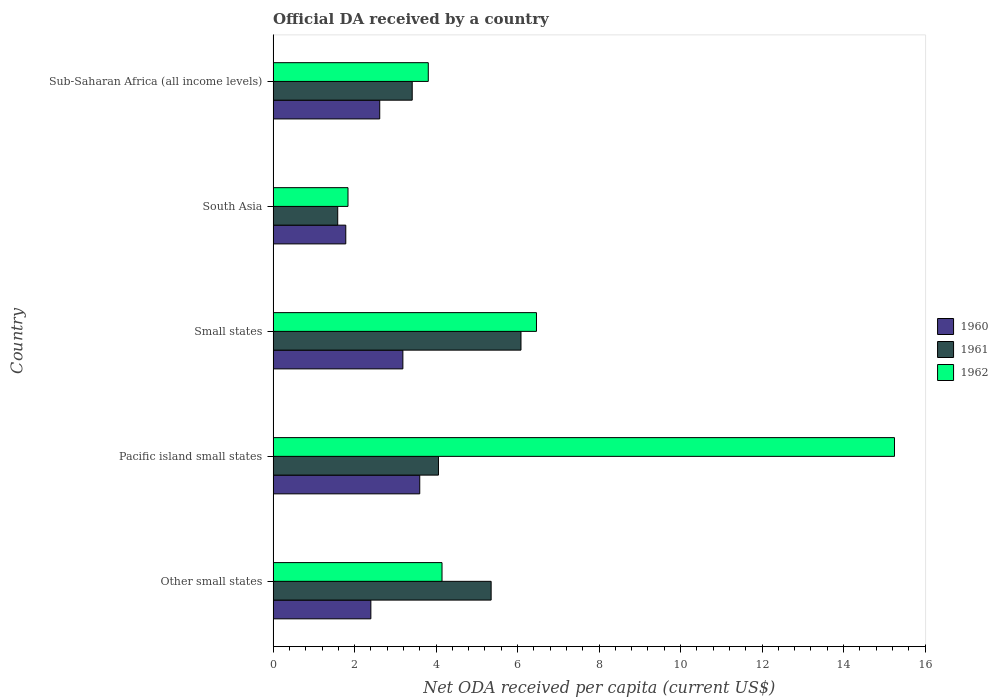Are the number of bars per tick equal to the number of legend labels?
Offer a very short reply. Yes. Are the number of bars on each tick of the Y-axis equal?
Keep it short and to the point. Yes. How many bars are there on the 5th tick from the bottom?
Keep it short and to the point. 3. What is the label of the 3rd group of bars from the top?
Give a very brief answer. Small states. What is the ODA received in in 1961 in Small states?
Your answer should be compact. 6.08. Across all countries, what is the maximum ODA received in in 1962?
Ensure brevity in your answer.  15.25. Across all countries, what is the minimum ODA received in in 1962?
Offer a very short reply. 1.84. In which country was the ODA received in in 1960 maximum?
Provide a succinct answer. Pacific island small states. What is the total ODA received in in 1961 in the graph?
Offer a very short reply. 20.49. What is the difference between the ODA received in in 1961 in Other small states and that in Pacific island small states?
Keep it short and to the point. 1.29. What is the difference between the ODA received in in 1961 in South Asia and the ODA received in in 1960 in Small states?
Offer a very short reply. -1.6. What is the average ODA received in in 1960 per country?
Provide a short and direct response. 2.72. What is the difference between the ODA received in in 1962 and ODA received in in 1961 in Pacific island small states?
Offer a terse response. 11.19. What is the ratio of the ODA received in in 1962 in Small states to that in South Asia?
Provide a succinct answer. 3.52. Is the ODA received in in 1962 in Pacific island small states less than that in South Asia?
Offer a terse response. No. Is the difference between the ODA received in in 1962 in Small states and South Asia greater than the difference between the ODA received in in 1961 in Small states and South Asia?
Offer a very short reply. Yes. What is the difference between the highest and the second highest ODA received in in 1962?
Your answer should be very brief. 8.79. What is the difference between the highest and the lowest ODA received in in 1961?
Provide a succinct answer. 4.5. What does the 2nd bar from the top in Small states represents?
Provide a short and direct response. 1961. What does the 1st bar from the bottom in Pacific island small states represents?
Ensure brevity in your answer.  1960. Is it the case that in every country, the sum of the ODA received in in 1961 and ODA received in in 1962 is greater than the ODA received in in 1960?
Your answer should be very brief. Yes. How many bars are there?
Offer a very short reply. 15. How many countries are there in the graph?
Give a very brief answer. 5. Are the values on the major ticks of X-axis written in scientific E-notation?
Your answer should be compact. No. What is the title of the graph?
Your answer should be very brief. Official DA received by a country. Does "1965" appear as one of the legend labels in the graph?
Your answer should be compact. No. What is the label or title of the X-axis?
Your answer should be compact. Net ODA received per capita (current US$). What is the Net ODA received per capita (current US$) in 1960 in Other small states?
Your response must be concise. 2.4. What is the Net ODA received per capita (current US$) in 1961 in Other small states?
Your answer should be compact. 5.35. What is the Net ODA received per capita (current US$) in 1962 in Other small states?
Make the answer very short. 4.15. What is the Net ODA received per capita (current US$) in 1960 in Pacific island small states?
Provide a short and direct response. 3.6. What is the Net ODA received per capita (current US$) in 1961 in Pacific island small states?
Make the answer very short. 4.06. What is the Net ODA received per capita (current US$) in 1962 in Pacific island small states?
Your answer should be compact. 15.25. What is the Net ODA received per capita (current US$) in 1960 in Small states?
Make the answer very short. 3.18. What is the Net ODA received per capita (current US$) in 1961 in Small states?
Provide a short and direct response. 6.08. What is the Net ODA received per capita (current US$) of 1962 in Small states?
Keep it short and to the point. 6.46. What is the Net ODA received per capita (current US$) of 1960 in South Asia?
Your response must be concise. 1.78. What is the Net ODA received per capita (current US$) of 1961 in South Asia?
Give a very brief answer. 1.59. What is the Net ODA received per capita (current US$) of 1962 in South Asia?
Keep it short and to the point. 1.84. What is the Net ODA received per capita (current US$) in 1960 in Sub-Saharan Africa (all income levels)?
Your answer should be compact. 2.62. What is the Net ODA received per capita (current US$) of 1961 in Sub-Saharan Africa (all income levels)?
Offer a terse response. 3.41. What is the Net ODA received per capita (current US$) in 1962 in Sub-Saharan Africa (all income levels)?
Your response must be concise. 3.81. Across all countries, what is the maximum Net ODA received per capita (current US$) of 1960?
Provide a short and direct response. 3.6. Across all countries, what is the maximum Net ODA received per capita (current US$) of 1961?
Offer a terse response. 6.08. Across all countries, what is the maximum Net ODA received per capita (current US$) in 1962?
Offer a very short reply. 15.25. Across all countries, what is the minimum Net ODA received per capita (current US$) in 1960?
Provide a short and direct response. 1.78. Across all countries, what is the minimum Net ODA received per capita (current US$) of 1961?
Your answer should be compact. 1.59. Across all countries, what is the minimum Net ODA received per capita (current US$) of 1962?
Offer a terse response. 1.84. What is the total Net ODA received per capita (current US$) in 1960 in the graph?
Keep it short and to the point. 13.58. What is the total Net ODA received per capita (current US$) in 1961 in the graph?
Keep it short and to the point. 20.49. What is the total Net ODA received per capita (current US$) of 1962 in the graph?
Provide a succinct answer. 31.51. What is the difference between the Net ODA received per capita (current US$) of 1961 in Other small states and that in Pacific island small states?
Provide a succinct answer. 1.29. What is the difference between the Net ODA received per capita (current US$) of 1962 in Other small states and that in Pacific island small states?
Provide a short and direct response. -11.11. What is the difference between the Net ODA received per capita (current US$) in 1960 in Other small states and that in Small states?
Offer a terse response. -0.79. What is the difference between the Net ODA received per capita (current US$) of 1961 in Other small states and that in Small states?
Give a very brief answer. -0.73. What is the difference between the Net ODA received per capita (current US$) of 1962 in Other small states and that in Small states?
Offer a very short reply. -2.32. What is the difference between the Net ODA received per capita (current US$) in 1960 in Other small states and that in South Asia?
Make the answer very short. 0.62. What is the difference between the Net ODA received per capita (current US$) in 1961 in Other small states and that in South Asia?
Provide a short and direct response. 3.77. What is the difference between the Net ODA received per capita (current US$) of 1962 in Other small states and that in South Asia?
Offer a terse response. 2.31. What is the difference between the Net ODA received per capita (current US$) of 1960 in Other small states and that in Sub-Saharan Africa (all income levels)?
Offer a terse response. -0.22. What is the difference between the Net ODA received per capita (current US$) in 1961 in Other small states and that in Sub-Saharan Africa (all income levels)?
Make the answer very short. 1.94. What is the difference between the Net ODA received per capita (current US$) of 1962 in Other small states and that in Sub-Saharan Africa (all income levels)?
Your answer should be very brief. 0.34. What is the difference between the Net ODA received per capita (current US$) in 1960 in Pacific island small states and that in Small states?
Provide a short and direct response. 0.41. What is the difference between the Net ODA received per capita (current US$) in 1961 in Pacific island small states and that in Small states?
Keep it short and to the point. -2.03. What is the difference between the Net ODA received per capita (current US$) in 1962 in Pacific island small states and that in Small states?
Provide a succinct answer. 8.79. What is the difference between the Net ODA received per capita (current US$) of 1960 in Pacific island small states and that in South Asia?
Your answer should be compact. 1.82. What is the difference between the Net ODA received per capita (current US$) in 1961 in Pacific island small states and that in South Asia?
Give a very brief answer. 2.47. What is the difference between the Net ODA received per capita (current US$) of 1962 in Pacific island small states and that in South Asia?
Provide a short and direct response. 13.41. What is the difference between the Net ODA received per capita (current US$) of 1960 in Pacific island small states and that in Sub-Saharan Africa (all income levels)?
Offer a very short reply. 0.98. What is the difference between the Net ODA received per capita (current US$) of 1961 in Pacific island small states and that in Sub-Saharan Africa (all income levels)?
Make the answer very short. 0.64. What is the difference between the Net ODA received per capita (current US$) of 1962 in Pacific island small states and that in Sub-Saharan Africa (all income levels)?
Provide a succinct answer. 11.44. What is the difference between the Net ODA received per capita (current US$) of 1960 in Small states and that in South Asia?
Keep it short and to the point. 1.4. What is the difference between the Net ODA received per capita (current US$) in 1961 in Small states and that in South Asia?
Your answer should be compact. 4.5. What is the difference between the Net ODA received per capita (current US$) of 1962 in Small states and that in South Asia?
Provide a succinct answer. 4.63. What is the difference between the Net ODA received per capita (current US$) in 1960 in Small states and that in Sub-Saharan Africa (all income levels)?
Provide a short and direct response. 0.57. What is the difference between the Net ODA received per capita (current US$) of 1961 in Small states and that in Sub-Saharan Africa (all income levels)?
Your response must be concise. 2.67. What is the difference between the Net ODA received per capita (current US$) in 1962 in Small states and that in Sub-Saharan Africa (all income levels)?
Keep it short and to the point. 2.66. What is the difference between the Net ODA received per capita (current US$) in 1960 in South Asia and that in Sub-Saharan Africa (all income levels)?
Provide a succinct answer. -0.83. What is the difference between the Net ODA received per capita (current US$) in 1961 in South Asia and that in Sub-Saharan Africa (all income levels)?
Offer a terse response. -1.83. What is the difference between the Net ODA received per capita (current US$) of 1962 in South Asia and that in Sub-Saharan Africa (all income levels)?
Give a very brief answer. -1.97. What is the difference between the Net ODA received per capita (current US$) of 1960 in Other small states and the Net ODA received per capita (current US$) of 1961 in Pacific island small states?
Make the answer very short. -1.66. What is the difference between the Net ODA received per capita (current US$) of 1960 in Other small states and the Net ODA received per capita (current US$) of 1962 in Pacific island small states?
Provide a succinct answer. -12.85. What is the difference between the Net ODA received per capita (current US$) in 1961 in Other small states and the Net ODA received per capita (current US$) in 1962 in Pacific island small states?
Ensure brevity in your answer.  -9.9. What is the difference between the Net ODA received per capita (current US$) in 1960 in Other small states and the Net ODA received per capita (current US$) in 1961 in Small states?
Provide a short and direct response. -3.69. What is the difference between the Net ODA received per capita (current US$) of 1960 in Other small states and the Net ODA received per capita (current US$) of 1962 in Small states?
Your answer should be compact. -4.06. What is the difference between the Net ODA received per capita (current US$) of 1961 in Other small states and the Net ODA received per capita (current US$) of 1962 in Small states?
Your answer should be compact. -1.11. What is the difference between the Net ODA received per capita (current US$) of 1960 in Other small states and the Net ODA received per capita (current US$) of 1961 in South Asia?
Your response must be concise. 0.81. What is the difference between the Net ODA received per capita (current US$) of 1960 in Other small states and the Net ODA received per capita (current US$) of 1962 in South Asia?
Make the answer very short. 0.56. What is the difference between the Net ODA received per capita (current US$) of 1961 in Other small states and the Net ODA received per capita (current US$) of 1962 in South Asia?
Offer a very short reply. 3.51. What is the difference between the Net ODA received per capita (current US$) in 1960 in Other small states and the Net ODA received per capita (current US$) in 1961 in Sub-Saharan Africa (all income levels)?
Ensure brevity in your answer.  -1.02. What is the difference between the Net ODA received per capita (current US$) in 1960 in Other small states and the Net ODA received per capita (current US$) in 1962 in Sub-Saharan Africa (all income levels)?
Your response must be concise. -1.41. What is the difference between the Net ODA received per capita (current US$) of 1961 in Other small states and the Net ODA received per capita (current US$) of 1962 in Sub-Saharan Africa (all income levels)?
Ensure brevity in your answer.  1.54. What is the difference between the Net ODA received per capita (current US$) in 1960 in Pacific island small states and the Net ODA received per capita (current US$) in 1961 in Small states?
Give a very brief answer. -2.48. What is the difference between the Net ODA received per capita (current US$) in 1960 in Pacific island small states and the Net ODA received per capita (current US$) in 1962 in Small states?
Your answer should be compact. -2.86. What is the difference between the Net ODA received per capita (current US$) in 1961 in Pacific island small states and the Net ODA received per capita (current US$) in 1962 in Small states?
Ensure brevity in your answer.  -2.41. What is the difference between the Net ODA received per capita (current US$) of 1960 in Pacific island small states and the Net ODA received per capita (current US$) of 1961 in South Asia?
Offer a terse response. 2.01. What is the difference between the Net ODA received per capita (current US$) of 1960 in Pacific island small states and the Net ODA received per capita (current US$) of 1962 in South Asia?
Your answer should be very brief. 1.76. What is the difference between the Net ODA received per capita (current US$) of 1961 in Pacific island small states and the Net ODA received per capita (current US$) of 1962 in South Asia?
Your answer should be compact. 2.22. What is the difference between the Net ODA received per capita (current US$) in 1960 in Pacific island small states and the Net ODA received per capita (current US$) in 1961 in Sub-Saharan Africa (all income levels)?
Provide a short and direct response. 0.18. What is the difference between the Net ODA received per capita (current US$) of 1960 in Pacific island small states and the Net ODA received per capita (current US$) of 1962 in Sub-Saharan Africa (all income levels)?
Your answer should be compact. -0.21. What is the difference between the Net ODA received per capita (current US$) in 1961 in Pacific island small states and the Net ODA received per capita (current US$) in 1962 in Sub-Saharan Africa (all income levels)?
Offer a very short reply. 0.25. What is the difference between the Net ODA received per capita (current US$) of 1960 in Small states and the Net ODA received per capita (current US$) of 1961 in South Asia?
Provide a short and direct response. 1.6. What is the difference between the Net ODA received per capita (current US$) in 1960 in Small states and the Net ODA received per capita (current US$) in 1962 in South Asia?
Give a very brief answer. 1.35. What is the difference between the Net ODA received per capita (current US$) of 1961 in Small states and the Net ODA received per capita (current US$) of 1962 in South Asia?
Your answer should be compact. 4.25. What is the difference between the Net ODA received per capita (current US$) of 1960 in Small states and the Net ODA received per capita (current US$) of 1961 in Sub-Saharan Africa (all income levels)?
Ensure brevity in your answer.  -0.23. What is the difference between the Net ODA received per capita (current US$) in 1960 in Small states and the Net ODA received per capita (current US$) in 1962 in Sub-Saharan Africa (all income levels)?
Offer a very short reply. -0.62. What is the difference between the Net ODA received per capita (current US$) of 1961 in Small states and the Net ODA received per capita (current US$) of 1962 in Sub-Saharan Africa (all income levels)?
Keep it short and to the point. 2.28. What is the difference between the Net ODA received per capita (current US$) of 1960 in South Asia and the Net ODA received per capita (current US$) of 1961 in Sub-Saharan Africa (all income levels)?
Provide a short and direct response. -1.63. What is the difference between the Net ODA received per capita (current US$) of 1960 in South Asia and the Net ODA received per capita (current US$) of 1962 in Sub-Saharan Africa (all income levels)?
Your response must be concise. -2.02. What is the difference between the Net ODA received per capita (current US$) of 1961 in South Asia and the Net ODA received per capita (current US$) of 1962 in Sub-Saharan Africa (all income levels)?
Keep it short and to the point. -2.22. What is the average Net ODA received per capita (current US$) in 1960 per country?
Offer a terse response. 2.72. What is the average Net ODA received per capita (current US$) of 1961 per country?
Offer a very short reply. 4.1. What is the average Net ODA received per capita (current US$) of 1962 per country?
Offer a very short reply. 6.3. What is the difference between the Net ODA received per capita (current US$) in 1960 and Net ODA received per capita (current US$) in 1961 in Other small states?
Offer a very short reply. -2.95. What is the difference between the Net ODA received per capita (current US$) in 1960 and Net ODA received per capita (current US$) in 1962 in Other small states?
Keep it short and to the point. -1.75. What is the difference between the Net ODA received per capita (current US$) of 1961 and Net ODA received per capita (current US$) of 1962 in Other small states?
Your answer should be very brief. 1.21. What is the difference between the Net ODA received per capita (current US$) of 1960 and Net ODA received per capita (current US$) of 1961 in Pacific island small states?
Your answer should be very brief. -0.46. What is the difference between the Net ODA received per capita (current US$) of 1960 and Net ODA received per capita (current US$) of 1962 in Pacific island small states?
Offer a very short reply. -11.65. What is the difference between the Net ODA received per capita (current US$) of 1961 and Net ODA received per capita (current US$) of 1962 in Pacific island small states?
Keep it short and to the point. -11.19. What is the difference between the Net ODA received per capita (current US$) in 1960 and Net ODA received per capita (current US$) in 1961 in Small states?
Give a very brief answer. -2.9. What is the difference between the Net ODA received per capita (current US$) of 1960 and Net ODA received per capita (current US$) of 1962 in Small states?
Give a very brief answer. -3.28. What is the difference between the Net ODA received per capita (current US$) in 1961 and Net ODA received per capita (current US$) in 1962 in Small states?
Your answer should be compact. -0.38. What is the difference between the Net ODA received per capita (current US$) in 1960 and Net ODA received per capita (current US$) in 1961 in South Asia?
Ensure brevity in your answer.  0.2. What is the difference between the Net ODA received per capita (current US$) of 1960 and Net ODA received per capita (current US$) of 1962 in South Asia?
Your answer should be very brief. -0.05. What is the difference between the Net ODA received per capita (current US$) of 1961 and Net ODA received per capita (current US$) of 1962 in South Asia?
Make the answer very short. -0.25. What is the difference between the Net ODA received per capita (current US$) in 1960 and Net ODA received per capita (current US$) in 1961 in Sub-Saharan Africa (all income levels)?
Offer a terse response. -0.8. What is the difference between the Net ODA received per capita (current US$) of 1960 and Net ODA received per capita (current US$) of 1962 in Sub-Saharan Africa (all income levels)?
Your answer should be compact. -1.19. What is the difference between the Net ODA received per capita (current US$) in 1961 and Net ODA received per capita (current US$) in 1962 in Sub-Saharan Africa (all income levels)?
Offer a terse response. -0.39. What is the ratio of the Net ODA received per capita (current US$) of 1960 in Other small states to that in Pacific island small states?
Your response must be concise. 0.67. What is the ratio of the Net ODA received per capita (current US$) of 1961 in Other small states to that in Pacific island small states?
Give a very brief answer. 1.32. What is the ratio of the Net ODA received per capita (current US$) of 1962 in Other small states to that in Pacific island small states?
Provide a short and direct response. 0.27. What is the ratio of the Net ODA received per capita (current US$) in 1960 in Other small states to that in Small states?
Keep it short and to the point. 0.75. What is the ratio of the Net ODA received per capita (current US$) of 1961 in Other small states to that in Small states?
Provide a short and direct response. 0.88. What is the ratio of the Net ODA received per capita (current US$) of 1962 in Other small states to that in Small states?
Ensure brevity in your answer.  0.64. What is the ratio of the Net ODA received per capita (current US$) of 1960 in Other small states to that in South Asia?
Your answer should be very brief. 1.35. What is the ratio of the Net ODA received per capita (current US$) in 1961 in Other small states to that in South Asia?
Your answer should be compact. 3.37. What is the ratio of the Net ODA received per capita (current US$) of 1962 in Other small states to that in South Asia?
Offer a terse response. 2.26. What is the ratio of the Net ODA received per capita (current US$) in 1960 in Other small states to that in Sub-Saharan Africa (all income levels)?
Make the answer very short. 0.92. What is the ratio of the Net ODA received per capita (current US$) in 1961 in Other small states to that in Sub-Saharan Africa (all income levels)?
Offer a terse response. 1.57. What is the ratio of the Net ODA received per capita (current US$) of 1962 in Other small states to that in Sub-Saharan Africa (all income levels)?
Keep it short and to the point. 1.09. What is the ratio of the Net ODA received per capita (current US$) of 1960 in Pacific island small states to that in Small states?
Ensure brevity in your answer.  1.13. What is the ratio of the Net ODA received per capita (current US$) of 1961 in Pacific island small states to that in Small states?
Provide a succinct answer. 0.67. What is the ratio of the Net ODA received per capita (current US$) of 1962 in Pacific island small states to that in Small states?
Give a very brief answer. 2.36. What is the ratio of the Net ODA received per capita (current US$) of 1960 in Pacific island small states to that in South Asia?
Offer a terse response. 2.02. What is the ratio of the Net ODA received per capita (current US$) of 1961 in Pacific island small states to that in South Asia?
Your answer should be very brief. 2.56. What is the ratio of the Net ODA received per capita (current US$) in 1962 in Pacific island small states to that in South Asia?
Offer a terse response. 8.3. What is the ratio of the Net ODA received per capita (current US$) of 1960 in Pacific island small states to that in Sub-Saharan Africa (all income levels)?
Offer a very short reply. 1.38. What is the ratio of the Net ODA received per capita (current US$) of 1961 in Pacific island small states to that in Sub-Saharan Africa (all income levels)?
Keep it short and to the point. 1.19. What is the ratio of the Net ODA received per capita (current US$) in 1962 in Pacific island small states to that in Sub-Saharan Africa (all income levels)?
Ensure brevity in your answer.  4. What is the ratio of the Net ODA received per capita (current US$) in 1960 in Small states to that in South Asia?
Ensure brevity in your answer.  1.79. What is the ratio of the Net ODA received per capita (current US$) in 1961 in Small states to that in South Asia?
Keep it short and to the point. 3.84. What is the ratio of the Net ODA received per capita (current US$) of 1962 in Small states to that in South Asia?
Keep it short and to the point. 3.52. What is the ratio of the Net ODA received per capita (current US$) of 1960 in Small states to that in Sub-Saharan Africa (all income levels)?
Provide a succinct answer. 1.22. What is the ratio of the Net ODA received per capita (current US$) in 1961 in Small states to that in Sub-Saharan Africa (all income levels)?
Offer a terse response. 1.78. What is the ratio of the Net ODA received per capita (current US$) of 1962 in Small states to that in Sub-Saharan Africa (all income levels)?
Give a very brief answer. 1.7. What is the ratio of the Net ODA received per capita (current US$) in 1960 in South Asia to that in Sub-Saharan Africa (all income levels)?
Make the answer very short. 0.68. What is the ratio of the Net ODA received per capita (current US$) in 1961 in South Asia to that in Sub-Saharan Africa (all income levels)?
Your answer should be very brief. 0.46. What is the ratio of the Net ODA received per capita (current US$) of 1962 in South Asia to that in Sub-Saharan Africa (all income levels)?
Make the answer very short. 0.48. What is the difference between the highest and the second highest Net ODA received per capita (current US$) of 1960?
Your answer should be very brief. 0.41. What is the difference between the highest and the second highest Net ODA received per capita (current US$) in 1961?
Your response must be concise. 0.73. What is the difference between the highest and the second highest Net ODA received per capita (current US$) in 1962?
Your response must be concise. 8.79. What is the difference between the highest and the lowest Net ODA received per capita (current US$) of 1960?
Make the answer very short. 1.82. What is the difference between the highest and the lowest Net ODA received per capita (current US$) of 1961?
Make the answer very short. 4.5. What is the difference between the highest and the lowest Net ODA received per capita (current US$) of 1962?
Your answer should be compact. 13.41. 